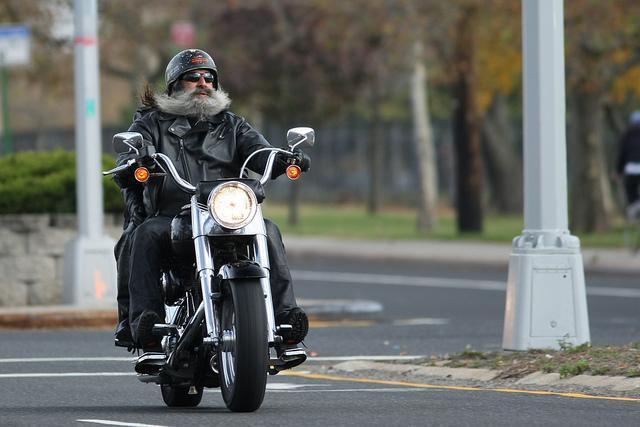What does the brown hair belong to?
Answer the question by selecting the correct answer among the 4 following choices and explain your choice with a short sentence. The answer should be formatted with the following format: `Answer: choice
Rationale: rationale.`
Options: Driver's hood, someone's hair, driver's dog, driver's beard. Answer: someone's hair.
Rationale: The motorcycler's beard has a bit of brown on the ends. 